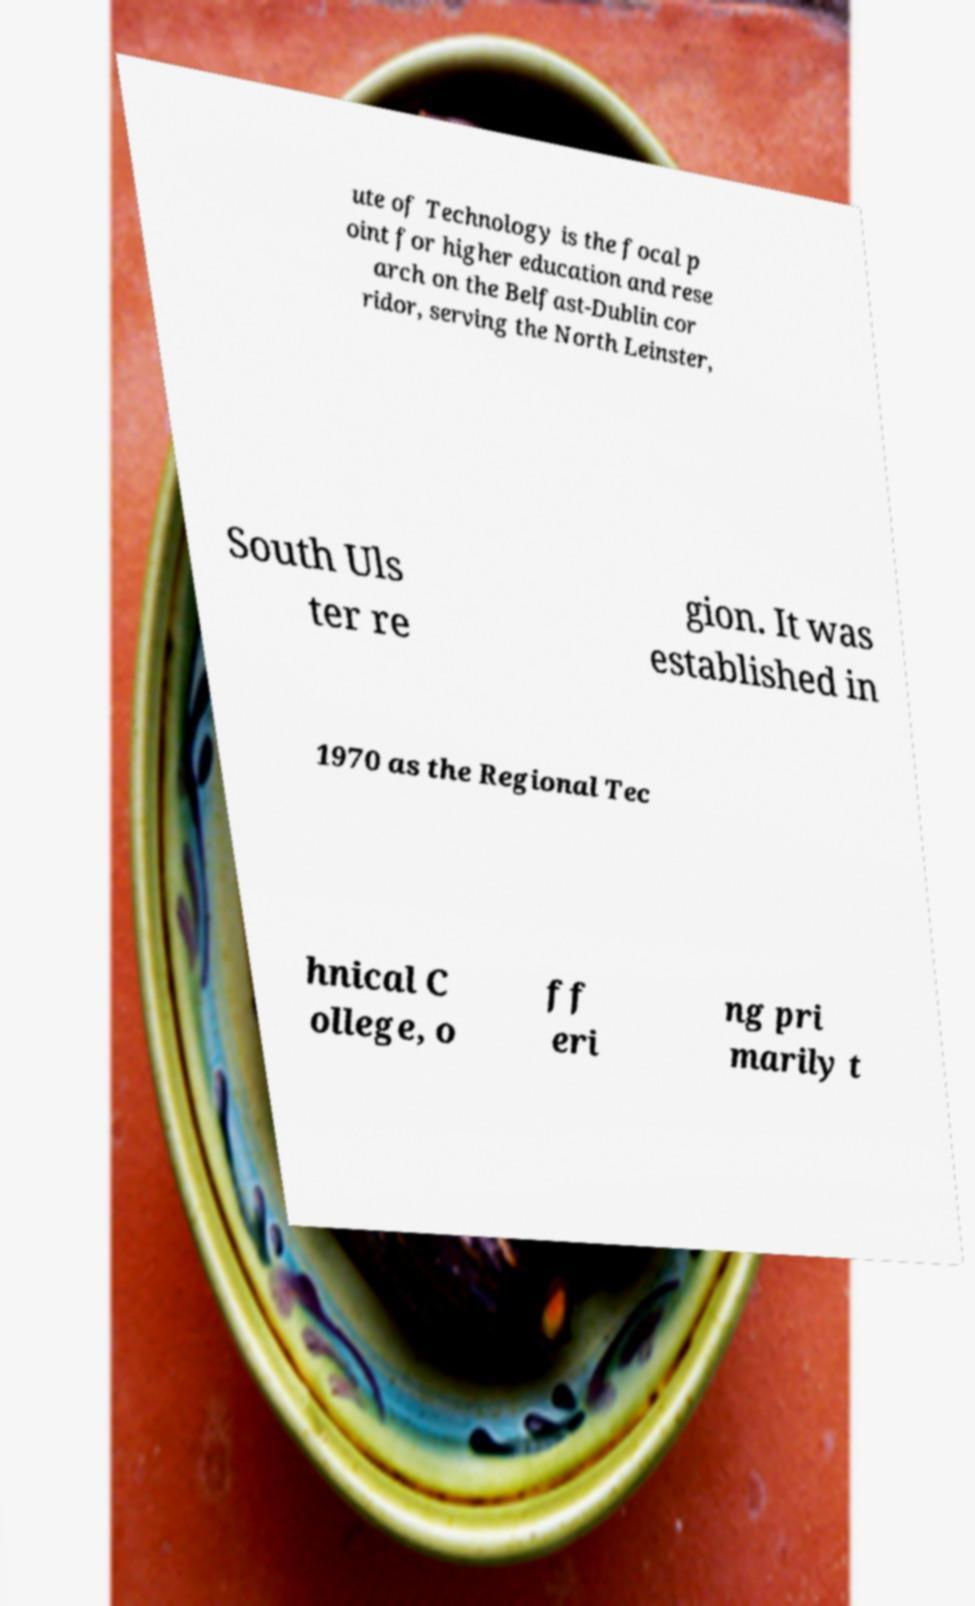I need the written content from this picture converted into text. Can you do that? ute of Technology is the focal p oint for higher education and rese arch on the Belfast-Dublin cor ridor, serving the North Leinster, South Uls ter re gion. It was established in 1970 as the Regional Tec hnical C ollege, o ff eri ng pri marily t 